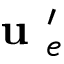<formula> <loc_0><loc_0><loc_500><loc_500>u _ { e } ^ { \prime }</formula> 